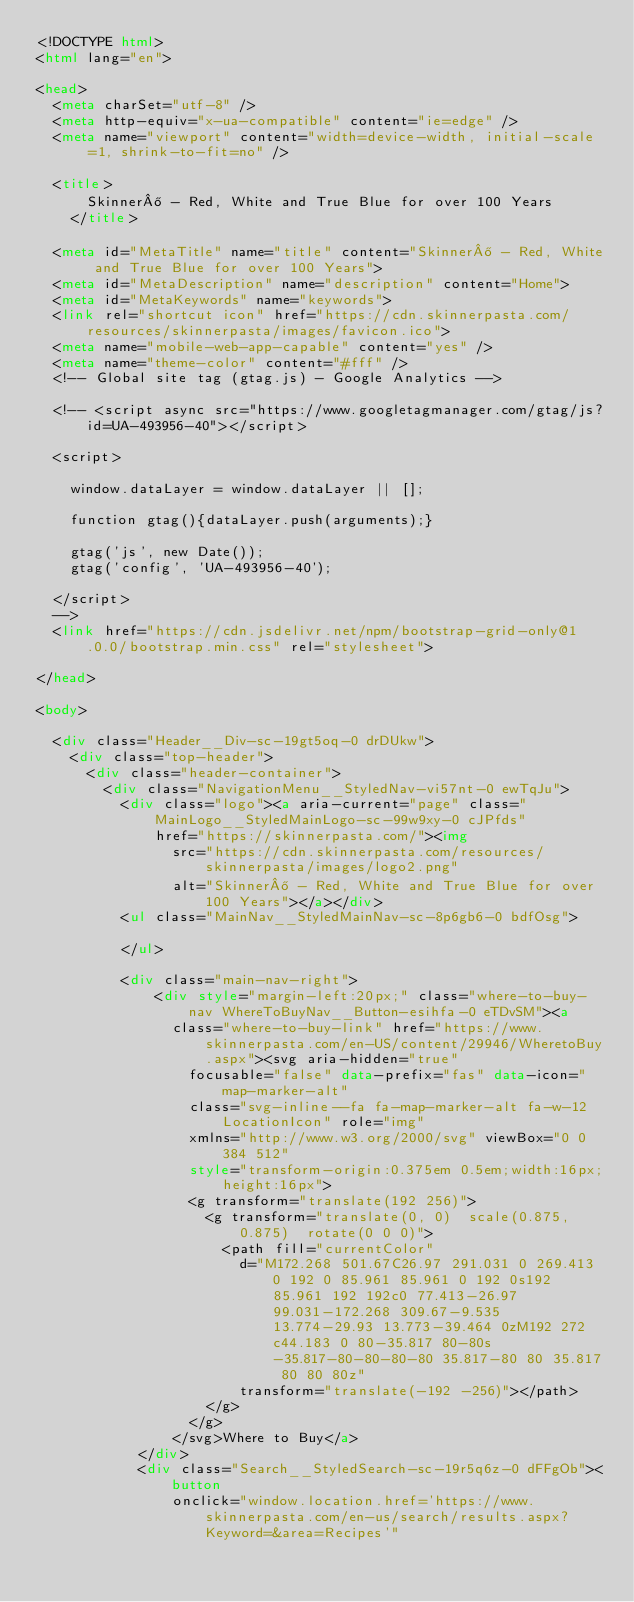<code> <loc_0><loc_0><loc_500><loc_500><_HTML_><!DOCTYPE html>
<html lang="en">

<head>
  <meta charSet="utf-8" />
  <meta http-equiv="x-ua-compatible" content="ie=edge" />
  <meta name="viewport" content="width=device-width, initial-scale=1, shrink-to-fit=no" />

  <title>
      Skinner® - Red, White and True Blue for over 100 Years
    </title>

  <meta id="MetaTitle" name="title" content="Skinner® - Red, White and True Blue for over 100 Years">
  <meta id="MetaDescription" name="description" content="Home">
  <meta id="MetaKeywords" name="keywords">
  <link rel="shortcut icon" href="https://cdn.skinnerpasta.com/resources/skinnerpasta/images/favicon.ico">
  <meta name="mobile-web-app-capable" content="yes" />
  <meta name="theme-color" content="#fff" />
  <!-- Global site tag (gtag.js) - Google Analytics -->

  <!-- <script async src="https://www.googletagmanager.com/gtag/js?id=UA-493956-40"></script>

  <script>

    window.dataLayer = window.dataLayer || [];

    function gtag(){dataLayer.push(arguments);}

    gtag('js', new Date());
    gtag('config', 'UA-493956-40');

  </script>
  -->
  <link href="https://cdn.jsdelivr.net/npm/bootstrap-grid-only@1.0.0/bootstrap.min.css" rel="stylesheet">
  
</head>

<body>

  <div class="Header__Div-sc-19gt5oq-0 drDUkw">
    <div class="top-header">
      <div class="header-container">
        <div class="NavigationMenu__StyledNav-vi57nt-0 ewTqJu">
          <div class="logo"><a aria-current="page" class="MainLogo__StyledMainLogo-sc-99w9xy-0 cJPfds"
              href="https://skinnerpasta.com/"><img
                src="https://cdn.skinnerpasta.com/resources/skinnerpasta/images/logo2.png"
                alt="Skinner® - Red, White and True Blue for over 100 Years"></a></div>
          <ul class="MainNav__StyledMainNav-sc-8p6gb6-0 bdfOsg">

          </ul>
          
          <div class="main-nav-right">
              <div style="margin-left:20px;" class="where-to-buy-nav WhereToBuyNav__Button-esihfa-0 eTDvSM"><a
                class="where-to-buy-link" href="https://www.skinnerpasta.com/en-US/content/29946/WheretoBuy.aspx"><svg aria-hidden="true"
                  focusable="false" data-prefix="fas" data-icon="map-marker-alt"
                  class="svg-inline--fa fa-map-marker-alt fa-w-12 LocationIcon" role="img"
                  xmlns="http://www.w3.org/2000/svg" viewBox="0 0 384 512"
                  style="transform-origin:0.375em 0.5em;width:16px;height:16px">
                  <g transform="translate(192 256)">
                    <g transform="translate(0, 0)  scale(0.875, 0.875)  rotate(0 0 0)">
                      <path fill="currentColor"
                        d="M172.268 501.67C26.97 291.031 0 269.413 0 192 0 85.961 85.961 0 192 0s192 85.961 192 192c0 77.413-26.97 99.031-172.268 309.67-9.535 13.774-29.93 13.773-39.464 0zM192 272c44.183 0 80-35.817 80-80s-35.817-80-80-80-80 35.817-80 80 35.817 80 80 80z"
                        transform="translate(-192 -256)"></path>
                    </g>
                  </g>
                </svg>Where to Buy</a>
            </div>
            <div class="Search__StyledSearch-sc-19r5q6z-0 dFFgOb"><button
                onclick="window.location.href='https://www.skinnerpasta.com/en-us/search/results.aspx?Keyword=&area=Recipes'"</code> 